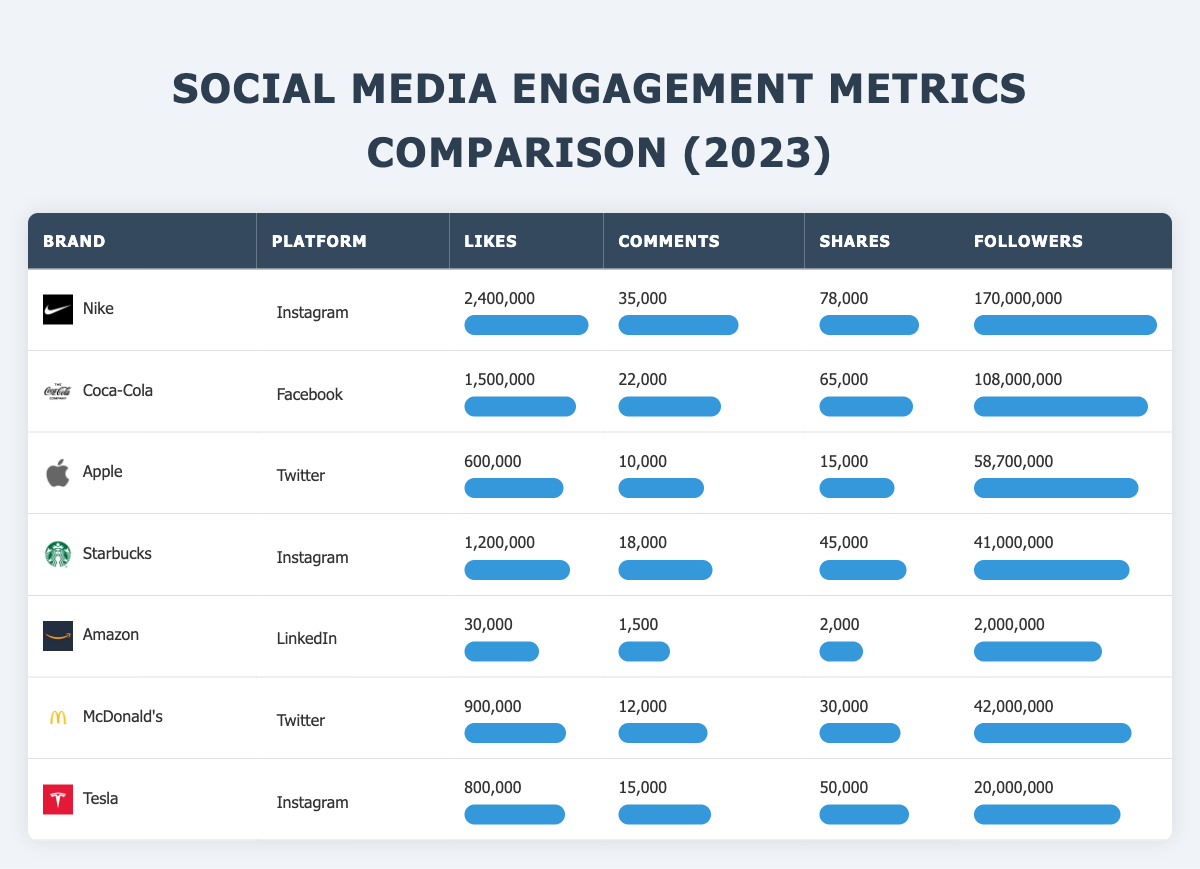What brand has the highest number of likes on social media? Looking at the table, Nike has 2,400,000 likes, which is the highest compared to other brands listed.
Answer: Nike Which platform has the most total followers among the listed brands? By examining the followers column, Nike has 170,000,000 followers, which is greater than any other brand listed.
Answer: Instagram What is the total number of shares for Coca-Cola and Starbucks combined? Coca-Cola has 65,000 shares and Starbucks has 45,000 shares. Adding them together gives 65,000 + 45,000 = 110,000 shares.
Answer: 110,000 Does Tesla have more likes on Instagram than McDonald's has on Twitter? Tesla has 800,000 likes on Instagram and McDonald's has 900,000 likes on Twitter. Therefore, Tesla has fewer likes than McDonald's.
Answer: No Which brand has the highest engagement in terms of likes per follower? To find this, calculate likes per follower: Nike = 2,400,000 / 170,000,000 = 0.0141; Coca-Cola = 1,500,000 / 108,000,000 = 0.0139; Apple = 600,000 / 58,700,000 = 0.0102; Starbucks = 1,200,000 / 41,000,000 = 0.0293. Starbucks has the highest engagement rate with 0.0293.
Answer: Starbucks What general trends can be observed regarding Instagram and Twitter engagement metrics? Comparing platforms, brands on Instagram generally show higher likes and comments than those on Twitter, which indicates better engagement on Instagram for the brands listed.
Answer: Instagram shows higher engagement How many more comments does Nike have compared to Apple? Nike has 35,000 comments while Apple has 10,000 comments. The difference is 35,000 - 10,000 = 25,000 comments.
Answer: 25,000 Is it true that Amazon has the least likes among all brands? Amazon has 30,000 likes, which is indeed lower than any other brand listed in the table.
Answer: Yes Which brand has the fewest followers, and what is the number? From the followers column, Amazon has 2,000,000 followers, which is the least compared to all other brands shown in the table.
Answer: Amazon, 2,000,000 